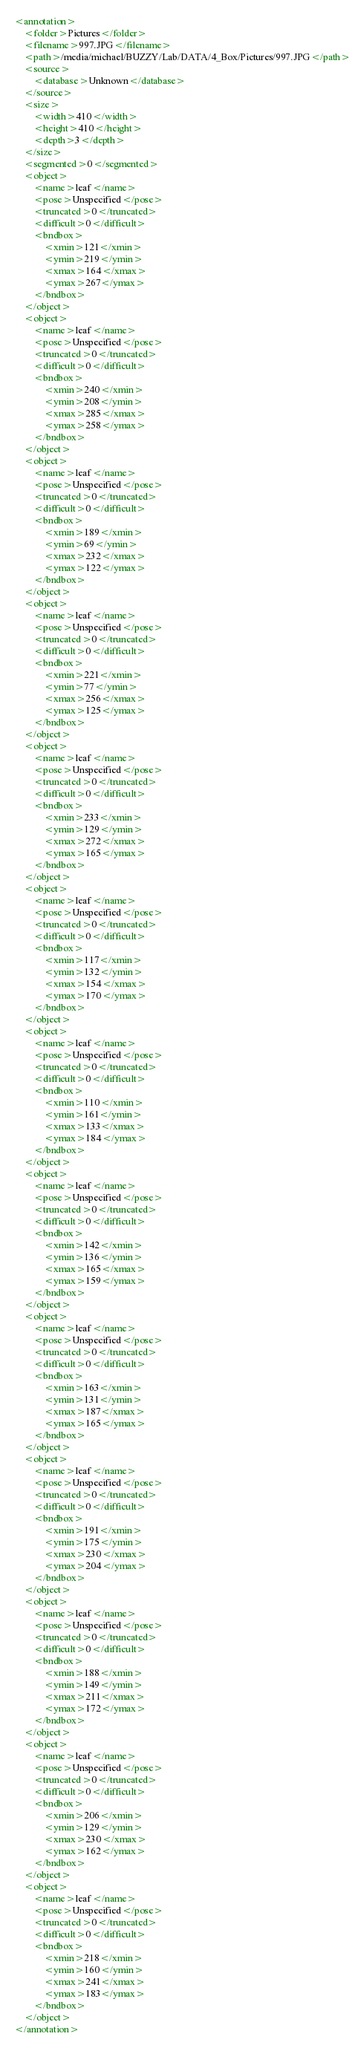Convert code to text. <code><loc_0><loc_0><loc_500><loc_500><_XML_>
<annotation>
    <folder>Pictures</folder>
    <filename>997.JPG</filename>
    <path>/media/michael/BUZZY/Lab/DATA/4_Box/Pictures/997.JPG</path>
    <source>
        <database>Unknown</database>
    </source>
    <size>
        <width>410</width>
        <height>410</height>
        <depth>3</depth>
    </size>
    <segmented>0</segmented>
    <object>
        <name>leaf</name>
        <pose>Unspecified</pose>
        <truncated>0</truncated>
        <difficult>0</difficult>
        <bndbox>
            <xmin>121</xmin>
            <ymin>219</ymin>
            <xmax>164</xmax>
            <ymax>267</ymax>
        </bndbox>
    </object>
    <object>
        <name>leaf</name>
        <pose>Unspecified</pose>
        <truncated>0</truncated>
        <difficult>0</difficult>
        <bndbox>
            <xmin>240</xmin>
            <ymin>208</ymin>
            <xmax>285</xmax>
            <ymax>258</ymax>
        </bndbox>
    </object>
    <object>
        <name>leaf</name>
        <pose>Unspecified</pose>
        <truncated>0</truncated>
        <difficult>0</difficult>
        <bndbox>
            <xmin>189</xmin>
            <ymin>69</ymin>
            <xmax>232</xmax>
            <ymax>122</ymax>
        </bndbox>
    </object>
    <object>
        <name>leaf</name>
        <pose>Unspecified</pose>
        <truncated>0</truncated>
        <difficult>0</difficult>
        <bndbox>
            <xmin>221</xmin>
            <ymin>77</ymin>
            <xmax>256</xmax>
            <ymax>125</ymax>
        </bndbox>
    </object>
    <object>
        <name>leaf</name>
        <pose>Unspecified</pose>
        <truncated>0</truncated>
        <difficult>0</difficult>
        <bndbox>
            <xmin>233</xmin>
            <ymin>129</ymin>
            <xmax>272</xmax>
            <ymax>165</ymax>
        </bndbox>
    </object>
    <object>
        <name>leaf</name>
        <pose>Unspecified</pose>
        <truncated>0</truncated>
        <difficult>0</difficult>
        <bndbox>
            <xmin>117</xmin>
            <ymin>132</ymin>
            <xmax>154</xmax>
            <ymax>170</ymax>
        </bndbox>
    </object>
    <object>
        <name>leaf</name>
        <pose>Unspecified</pose>
        <truncated>0</truncated>
        <difficult>0</difficult>
        <bndbox>
            <xmin>110</xmin>
            <ymin>161</ymin>
            <xmax>133</xmax>
            <ymax>184</ymax>
        </bndbox>
    </object>
    <object>
        <name>leaf</name>
        <pose>Unspecified</pose>
        <truncated>0</truncated>
        <difficult>0</difficult>
        <bndbox>
            <xmin>142</xmin>
            <ymin>136</ymin>
            <xmax>165</xmax>
            <ymax>159</ymax>
        </bndbox>
    </object>
    <object>
        <name>leaf</name>
        <pose>Unspecified</pose>
        <truncated>0</truncated>
        <difficult>0</difficult>
        <bndbox>
            <xmin>163</xmin>
            <ymin>131</ymin>
            <xmax>187</xmax>
            <ymax>165</ymax>
        </bndbox>
    </object>
    <object>
        <name>leaf</name>
        <pose>Unspecified</pose>
        <truncated>0</truncated>
        <difficult>0</difficult>
        <bndbox>
            <xmin>191</xmin>
            <ymin>175</ymin>
            <xmax>230</xmax>
            <ymax>204</ymax>
        </bndbox>
    </object>
    <object>
        <name>leaf</name>
        <pose>Unspecified</pose>
        <truncated>0</truncated>
        <difficult>0</difficult>
        <bndbox>
            <xmin>188</xmin>
            <ymin>149</ymin>
            <xmax>211</xmax>
            <ymax>172</ymax>
        </bndbox>
    </object>
    <object>
        <name>leaf</name>
        <pose>Unspecified</pose>
        <truncated>0</truncated>
        <difficult>0</difficult>
        <bndbox>
            <xmin>206</xmin>
            <ymin>129</ymin>
            <xmax>230</xmax>
            <ymax>162</ymax>
        </bndbox>
    </object>
    <object>
        <name>leaf</name>
        <pose>Unspecified</pose>
        <truncated>0</truncated>
        <difficult>0</difficult>
        <bndbox>
            <xmin>218</xmin>
            <ymin>160</ymin>
            <xmax>241</xmax>
            <ymax>183</ymax>
        </bndbox>
    </object>
</annotation>
</code> 